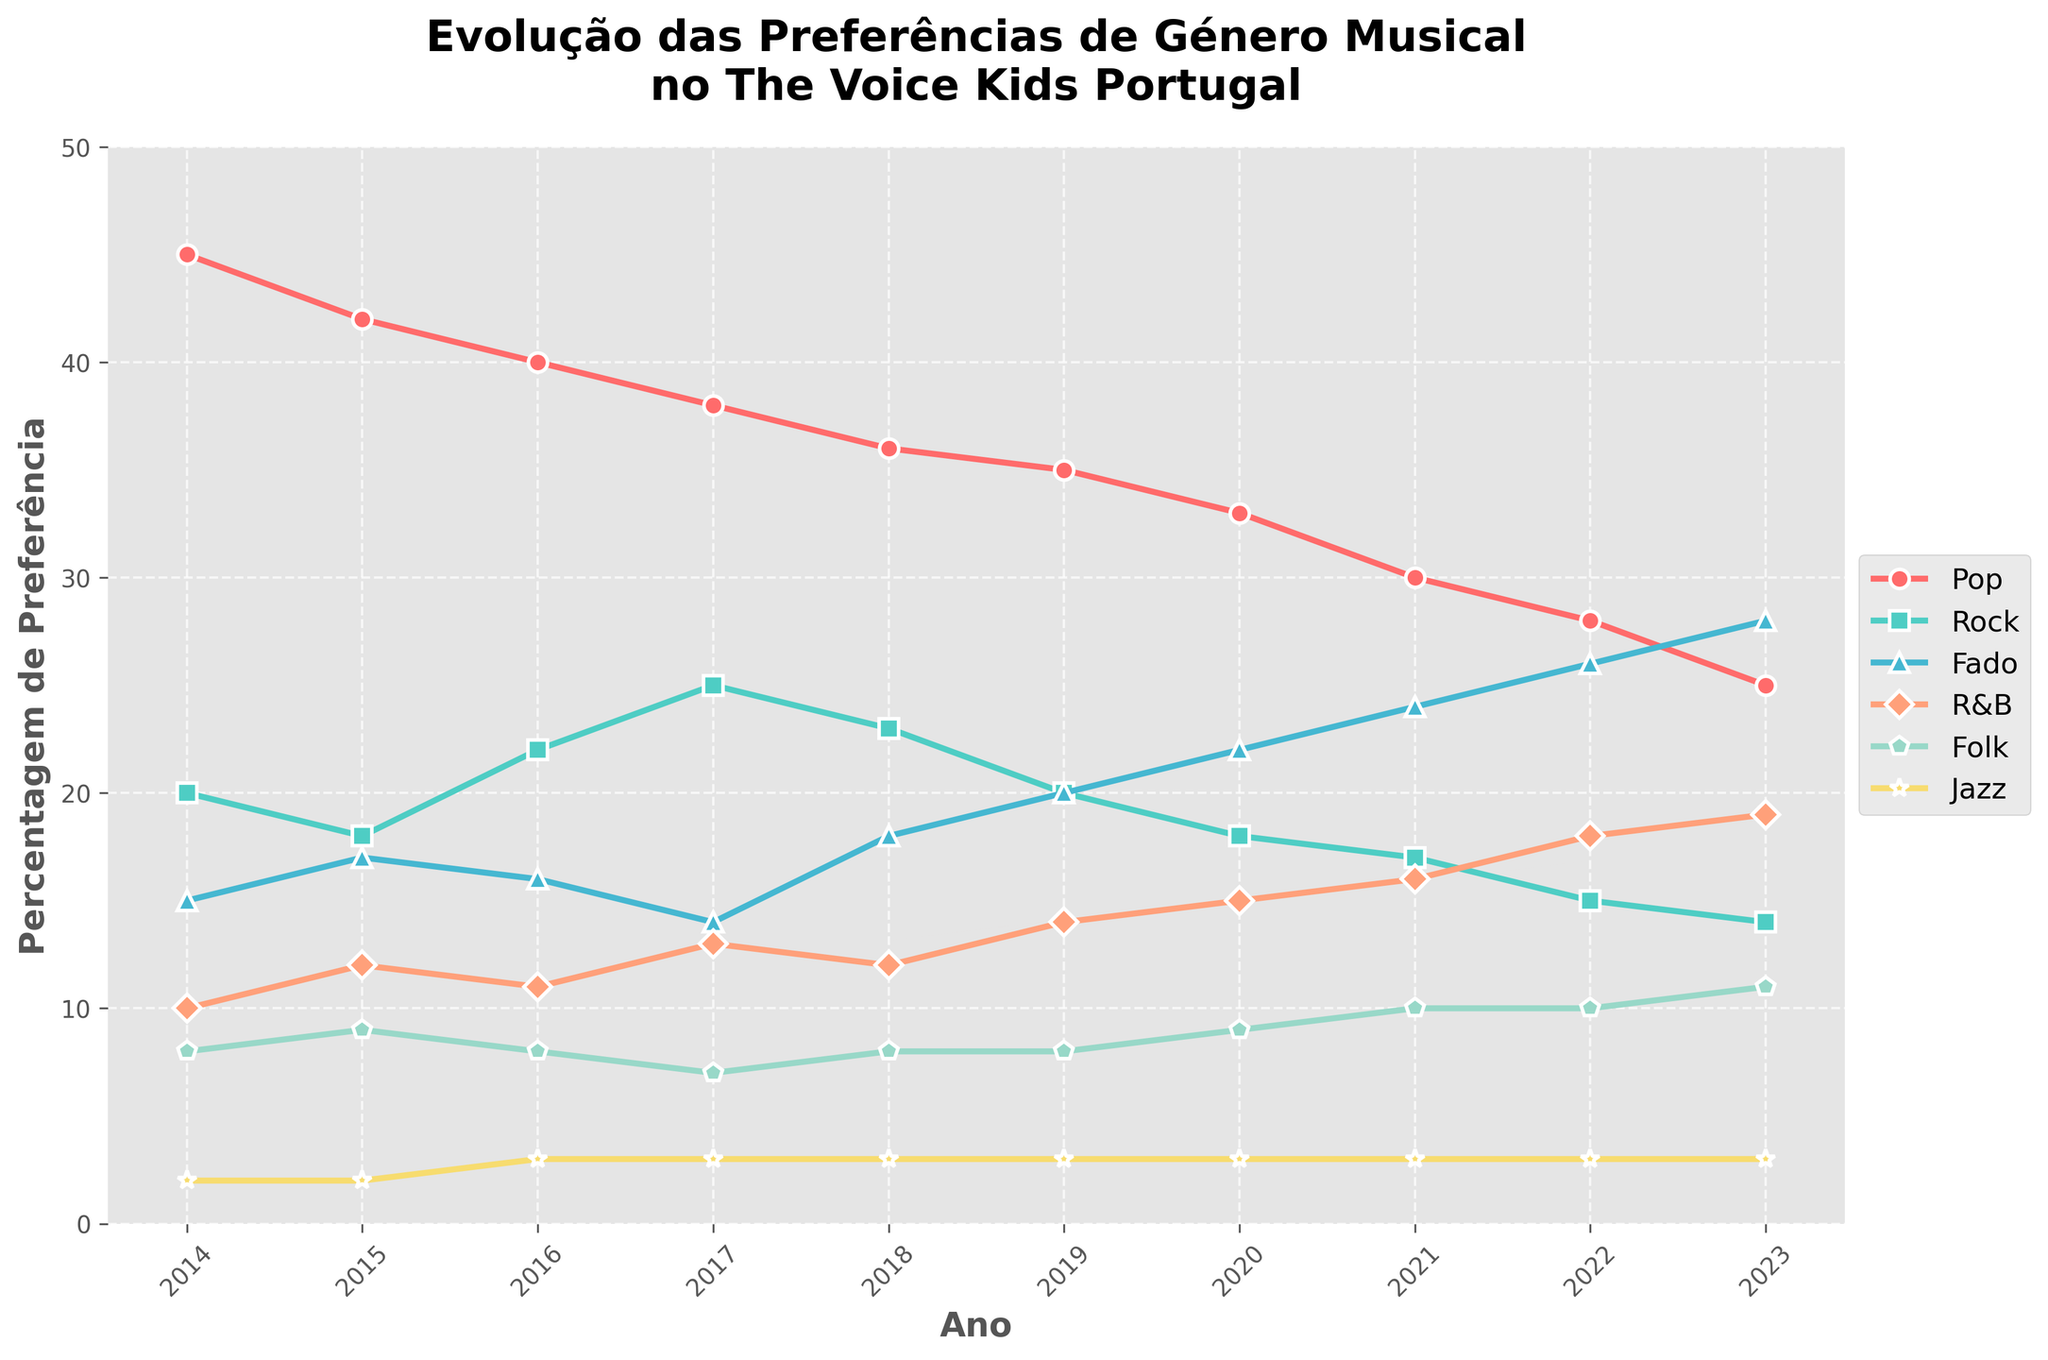What's the trend in the preference for Pop music from 2014 to 2023? The graph shows a significant decline in the preference for Pop music from 45% in 2014 to 25% in 2023.
Answer: Decline Which music genre showed the most significant increase in preference from 2014 to 2023? By observing the shifts in lines, Fado shows the largest increase, rising from 15% in 2014 to 28% in 2023.
Answer: Fado Between Rock and Jazz, which genre was more preferred in 2019? In 2019, the graph indicates that Rock had a preference of 20%, whereas Jazz had only 3%.
Answer: Rock What is the overall trend in preference for Jazz music over the years? The graph shows a consistent, but very low, preference for Jazz, ranging from 2% to 3% over the years.
Answer: Stable/Low What are the peak years of preference for R&B music? The graph shows increasing preference for R&B, peaking in 2023 at 19%.
Answer: 2023 Compare the preferences for Folk and Pop in 2023. Which one is higher and by how much? In 2023, Pop has a preference of 25%, while Folk has 11%. The difference is 25% - 11% = 14%.
Answer: Pop by 14% How did the preference for Fado change from 2017 to 2020? The graph shows that Fado's preference rose from 14% in 2017 to 22% in 2020.
Answer: Increased by 8% Which year experienced the most significant shift in Rock music preference from the previous year? The largest change in Rock preference occurs from 2016 to 2017, increasing from 22% to 25%.
Answer: 2017 What is the combined preference for Jazz over the entire period? Adding the percentages for each year (2+2+3+3+3+3+3+3+3+3) equals 30%.
Answer: 30% Was there a year when Pop and Fado had the same preference? By examining the lines, there is no year where Pop and Fado intersect; thus, they never had the same preference.
Answer: No 